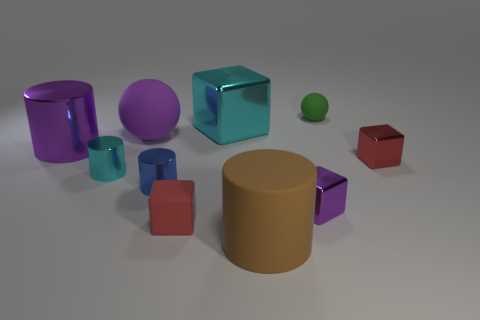Subtract all red cylinders. Subtract all gray blocks. How many cylinders are left? 4 Subtract all cylinders. How many objects are left? 6 Subtract all tiny yellow things. Subtract all big purple things. How many objects are left? 8 Add 7 tiny green things. How many tiny green things are left? 8 Add 5 small blue cylinders. How many small blue cylinders exist? 6 Subtract 0 yellow blocks. How many objects are left? 10 